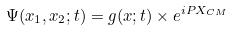Convert formula to latex. <formula><loc_0><loc_0><loc_500><loc_500>\Psi ( x _ { 1 } , x _ { 2 } ; t ) = g ( x ; t ) \times e ^ { i P X _ { C M } }</formula> 